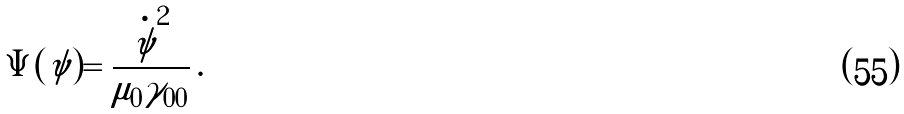<formula> <loc_0><loc_0><loc_500><loc_500>\Psi ( { \tilde { \psi } } ) = \frac { { \dot { \tilde { \psi } } } ^ { 2 } } { \mu _ { 0 } \gamma _ { 0 0 } } \, .</formula> 